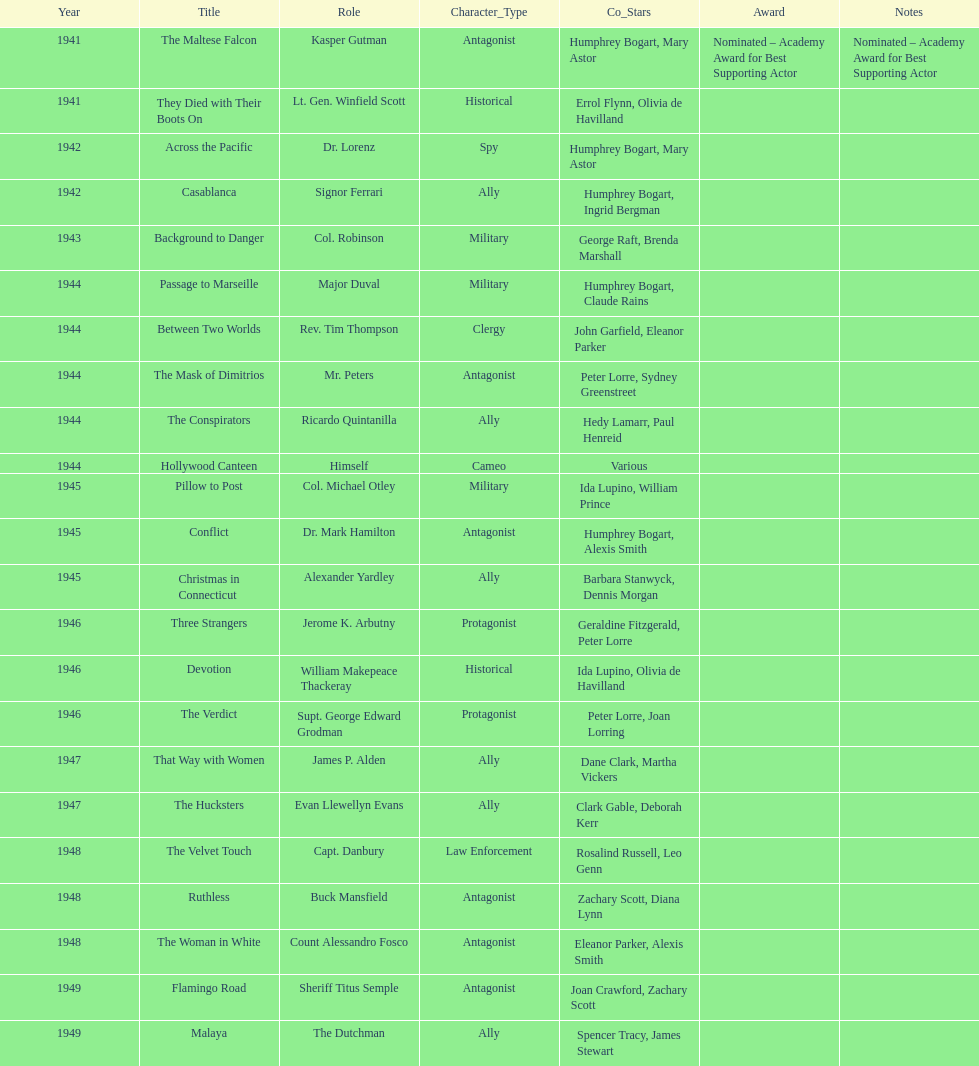Which movie did he get nominated for an oscar for? The Maltese Falcon. 